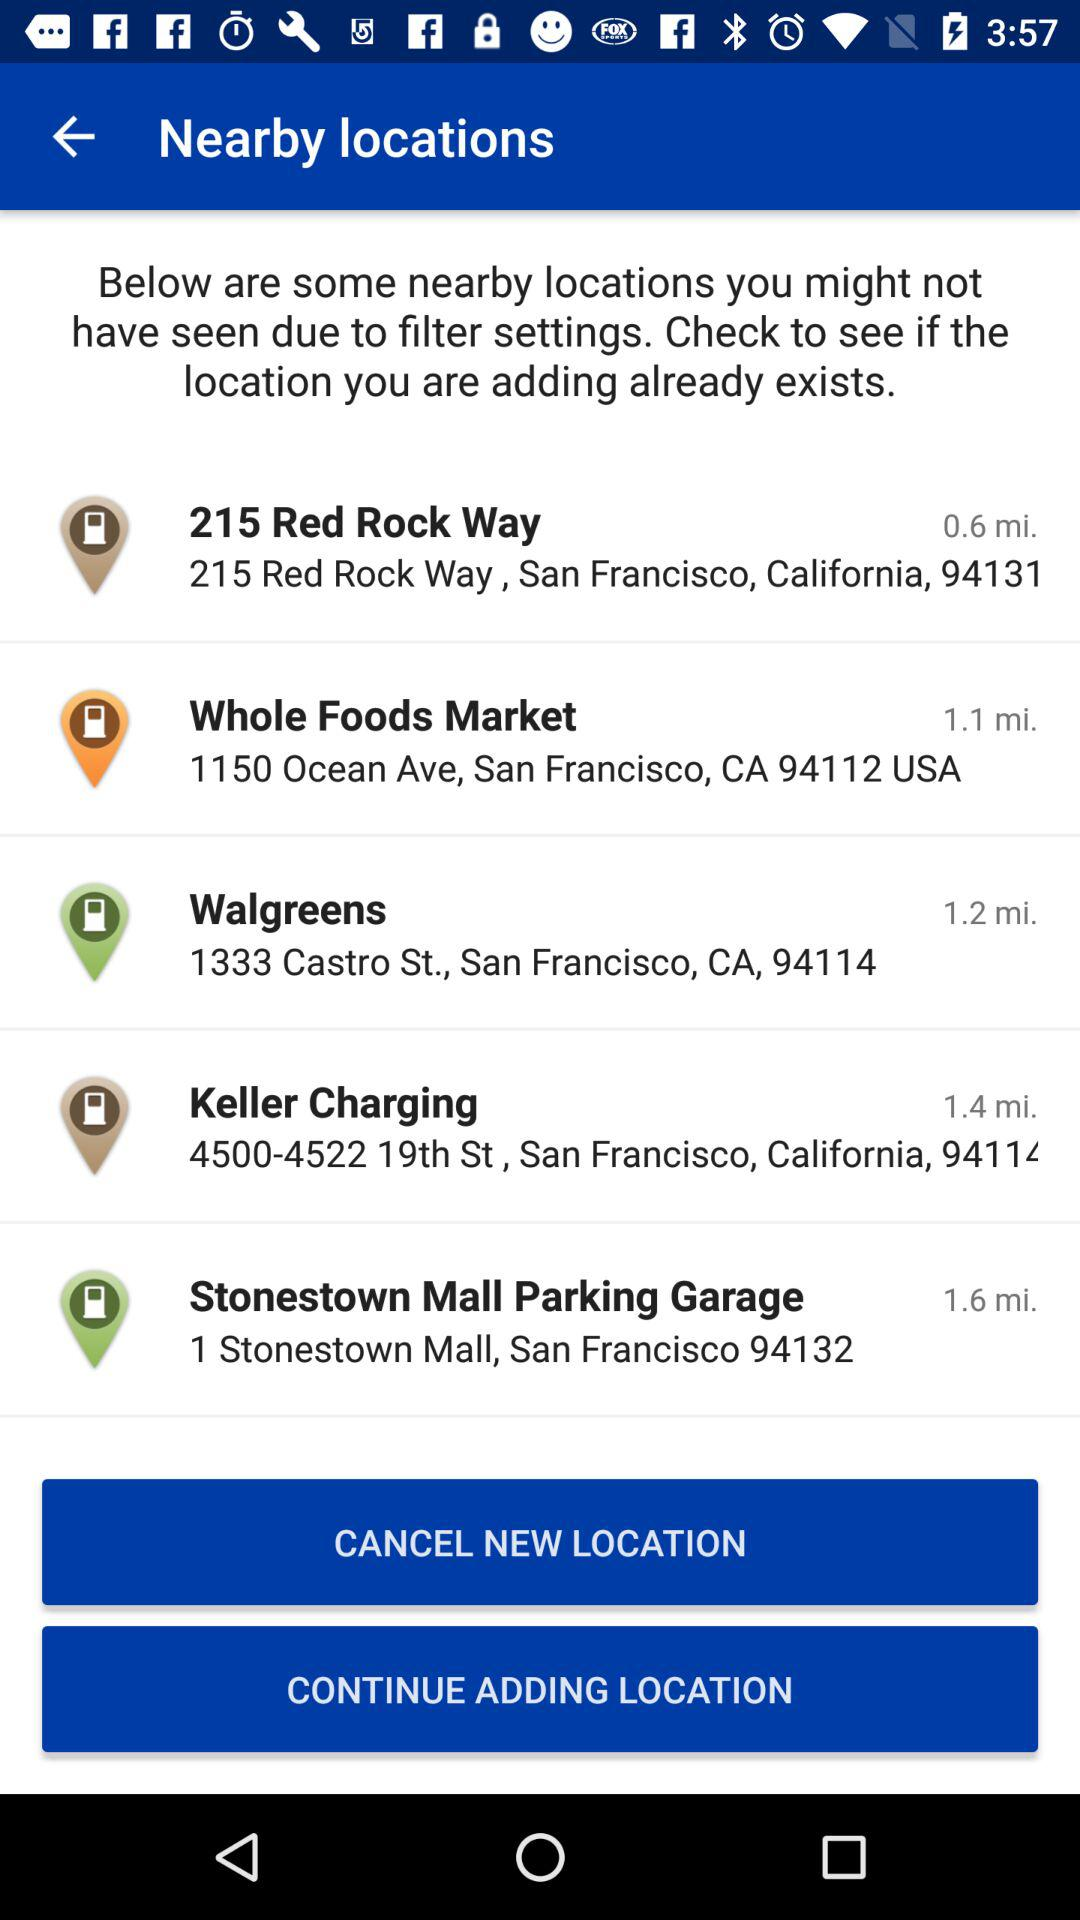What is the address of Keller Charging? The address is "4500-4522 19th St, San Francisco, California, 9411". 